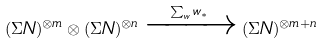<formula> <loc_0><loc_0><loc_500><loc_500>( \Sigma N ) ^ { \otimes m } \otimes ( \Sigma N ) ^ { \otimes n } \xrightarrow { \sum _ { w } w _ { * } } ( \Sigma N ) ^ { \otimes m + n }</formula> 